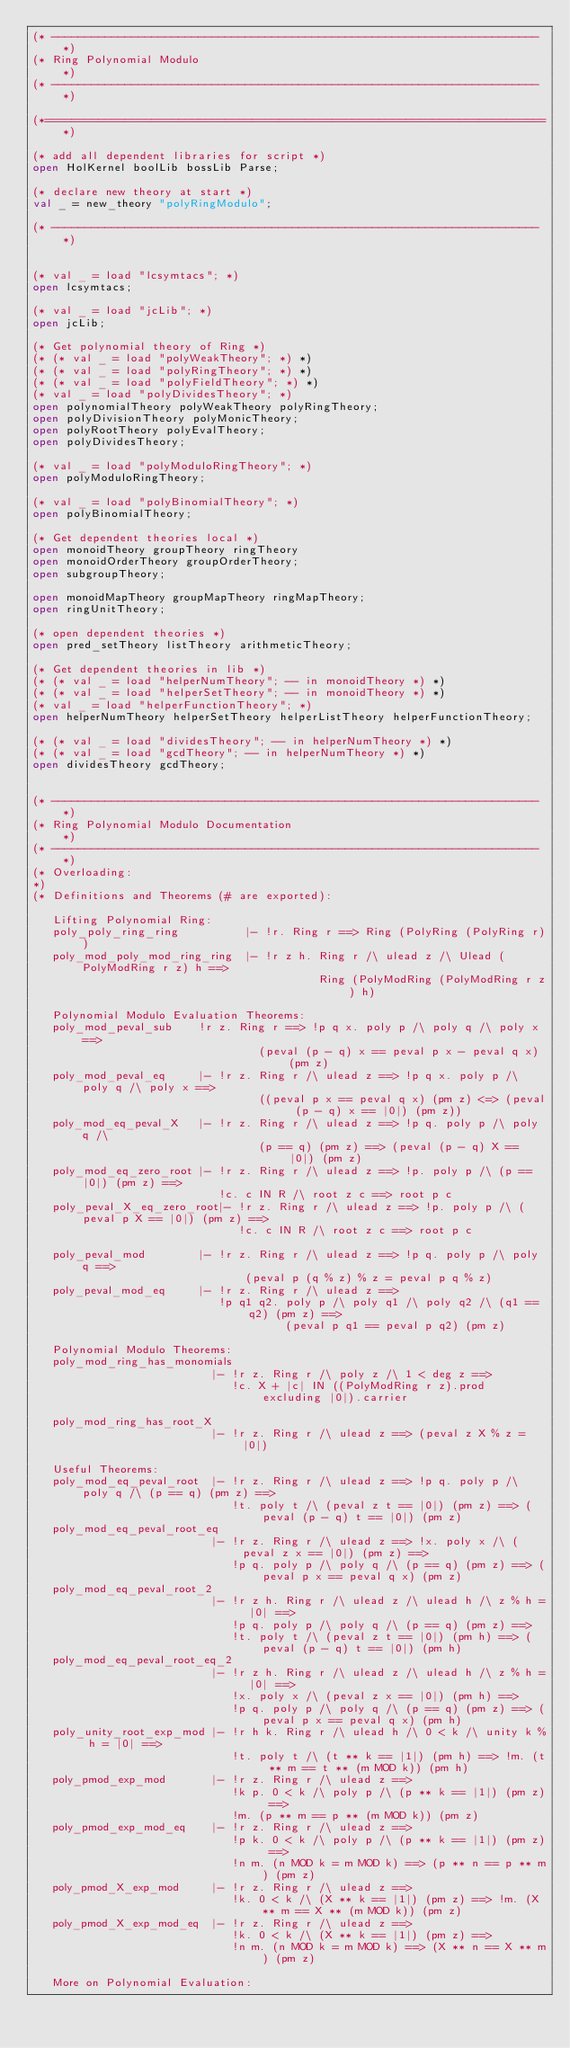Convert code to text. <code><loc_0><loc_0><loc_500><loc_500><_SML_>(* ------------------------------------------------------------------------- *)
(* Ring Polynomial Modulo                                                    *)
(* ------------------------------------------------------------------------- *)

(*===========================================================================*)

(* add all dependent libraries for script *)
open HolKernel boolLib bossLib Parse;

(* declare new theory at start *)
val _ = new_theory "polyRingModulo";

(* ------------------------------------------------------------------------- *)


(* val _ = load "lcsymtacs"; *)
open lcsymtacs;

(* val _ = load "jcLib"; *)
open jcLib;

(* Get polynomial theory of Ring *)
(* (* val _ = load "polyWeakTheory"; *) *)
(* (* val _ = load "polyRingTheory"; *) *)
(* (* val _ = load "polyFieldTheory"; *) *)
(* val _ = load "polyDividesTheory"; *)
open polynomialTheory polyWeakTheory polyRingTheory;
open polyDivisionTheory polyMonicTheory;
open polyRootTheory polyEvalTheory;
open polyDividesTheory;

(* val _ = load "polyModuloRingTheory"; *)
open polyModuloRingTheory;

(* val _ = load "polyBinomialTheory"; *)
open polyBinomialTheory;

(* Get dependent theories local *)
open monoidTheory groupTheory ringTheory
open monoidOrderTheory groupOrderTheory;
open subgroupTheory;

open monoidMapTheory groupMapTheory ringMapTheory;
open ringUnitTheory;

(* open dependent theories *)
open pred_setTheory listTheory arithmeticTheory;

(* Get dependent theories in lib *)
(* (* val _ = load "helperNumTheory"; -- in monoidTheory *) *)
(* (* val _ = load "helperSetTheory"; -- in monoidTheory *) *)
(* val _ = load "helperFunctionTheory"; *)
open helperNumTheory helperSetTheory helperListTheory helperFunctionTheory;

(* (* val _ = load "dividesTheory"; -- in helperNumTheory *) *)
(* (* val _ = load "gcdTheory"; -- in helperNumTheory *) *)
open dividesTheory gcdTheory;


(* ------------------------------------------------------------------------- *)
(* Ring Polynomial Modulo Documentation                                      *)
(* ------------------------------------------------------------------------- *)
(* Overloading:
*)
(* Definitions and Theorems (# are exported):

   Lifting Polynomial Ring:
   poly_poly_ring_ring          |- !r. Ring r ==> Ring (PolyRing (PolyRing r))
   poly_mod_poly_mod_ring_ring  |- !r z h. Ring r /\ ulead z /\ Ulead (PolyModRing r z) h ==>
                                           Ring (PolyModRing (PolyModRing r z) h)

   Polynomial Modulo Evaluation Theorems:
   poly_mod_peval_sub    !r z. Ring r ==> !p q x. poly p /\ poly q /\ poly x ==>
                                  (peval (p - q) x == peval p x - peval q x) (pm z)
   poly_mod_peval_eq     |- !r z. Ring r /\ ulead z ==> !p q x. poly p /\ poly q /\ poly x ==>
                                  ((peval p x == peval q x) (pm z) <=> (peval (p - q) x == |0|) (pm z))
   poly_mod_eq_peval_X   |- !r z. Ring r /\ ulead z ==> !p q. poly p /\ poly q /\
                                  (p == q) (pm z) ==> (peval (p - q) X == |0|) (pm z)
   poly_mod_eq_zero_root |- !r z. Ring r /\ ulead z ==> !p. poly p /\ (p == |0|) (pm z) ==>
                            !c. c IN R /\ root z c ==> root p c
   poly_peval_X_eq_zero_root|- !r z. Ring r /\ ulead z ==> !p. poly p /\ (peval p X == |0|) (pm z) ==>
                               !c. c IN R /\ root z c ==> root p c

   poly_peval_mod        |- !r z. Ring r /\ ulead z ==> !p q. poly p /\ poly q ==>
                                (peval p (q % z) % z = peval p q % z)
   poly_peval_mod_eq     |- !r z. Ring r /\ ulead z ==>
                            !p q1 q2. poly p /\ poly q1 /\ poly q2 /\ (q1 == q2) (pm z) ==>
                                      (peval p q1 == peval p q2) (pm z)

   Polynomial Modulo Theorems:
   poly_mod_ring_has_monomials
                           |- !r z. Ring r /\ poly z /\ 1 < deg z ==>
                              !c. X + |c| IN ((PolyModRing r z).prod excluding |0|).carrier

   poly_mod_ring_has_root_X
                           |- !r z. Ring r /\ ulead z ==> (peval z X % z = |0|)

   Useful Theorems:
   poly_mod_eq_peval_root  |- !r z. Ring r /\ ulead z ==> !p q. poly p /\ poly q /\ (p == q) (pm z) ==>
                              !t. poly t /\ (peval z t == |0|) (pm z) ==> (peval (p - q) t == |0|) (pm z)
   poly_mod_eq_peval_root_eq
                           |- !r z. Ring r /\ ulead z ==> !x. poly x /\ (peval z x == |0|) (pm z) ==>
                              !p q. poly p /\ poly q /\ (p == q) (pm z) ==> (peval p x == peval q x) (pm z)
   poly_mod_eq_peval_root_2
                           |- !r z h. Ring r /\ ulead z /\ ulead h /\ z % h = |0| ==>
                              !p q. poly p /\ poly q /\ (p == q) (pm z) ==>
                              !t. poly t /\ (peval z t == |0|) (pm h) ==> (peval (p - q) t == |0|) (pm h)
   poly_mod_eq_peval_root_eq_2
                           |- !r z h. Ring r /\ ulead z /\ ulead h /\ z % h = |0| ==>
                              !x. poly x /\ (peval z x == |0|) (pm h) ==>
                              !p q. poly p /\ poly q /\ (p == q) (pm z) ==> (peval p x == peval q x) (pm h)
   poly_unity_root_exp_mod |- !r h k. Ring r /\ ulead h /\ 0 < k /\ unity k % h = |0| ==>
                              !t. poly t /\ (t ** k == |1|) (pm h) ==> !m. (t ** m == t ** (m MOD k)) (pm h)
   poly_pmod_exp_mod       |- !r z. Ring r /\ ulead z ==>
                              !k p. 0 < k /\ poly p /\ (p ** k == |1|) (pm z) ==>
                              !m. (p ** m == p ** (m MOD k)) (pm z)
   poly_pmod_exp_mod_eq    |- !r z. Ring r /\ ulead z ==>
                              !p k. 0 < k /\ poly p /\ (p ** k == |1|) (pm z) ==>
                              !n m. (n MOD k = m MOD k) ==> (p ** n == p ** m) (pm z)
   poly_pmod_X_exp_mod     |- !r z. Ring r /\ ulead z ==>
                              !k. 0 < k /\ (X ** k == |1|) (pm z) ==> !m. (X ** m == X ** (m MOD k)) (pm z)
   poly_pmod_X_exp_mod_eq  |- !r z. Ring r /\ ulead z ==>
                              !k. 0 < k /\ (X ** k == |1|) (pm z) ==>
                              !n m. (n MOD k = m MOD k) ==> (X ** n == X ** m) (pm z)

   More on Polynomial Evaluation:</code> 